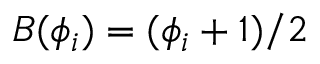<formula> <loc_0><loc_0><loc_500><loc_500>B ( \phi _ { i } ) = ( \phi _ { i } + 1 ) / 2</formula> 